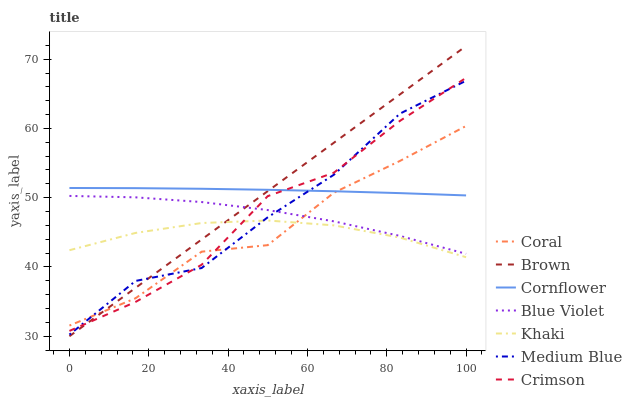Does Khaki have the minimum area under the curve?
Answer yes or no. Yes. Does Cornflower have the minimum area under the curve?
Answer yes or no. No. Does Khaki have the maximum area under the curve?
Answer yes or no. No. Is Medium Blue the roughest?
Answer yes or no. Yes. Is Khaki the smoothest?
Answer yes or no. No. Is Khaki the roughest?
Answer yes or no. No. Does Khaki have the lowest value?
Answer yes or no. No. Does Cornflower have the highest value?
Answer yes or no. No. Is Blue Violet less than Cornflower?
Answer yes or no. Yes. Is Blue Violet greater than Khaki?
Answer yes or no. Yes. Does Blue Violet intersect Cornflower?
Answer yes or no. No. 